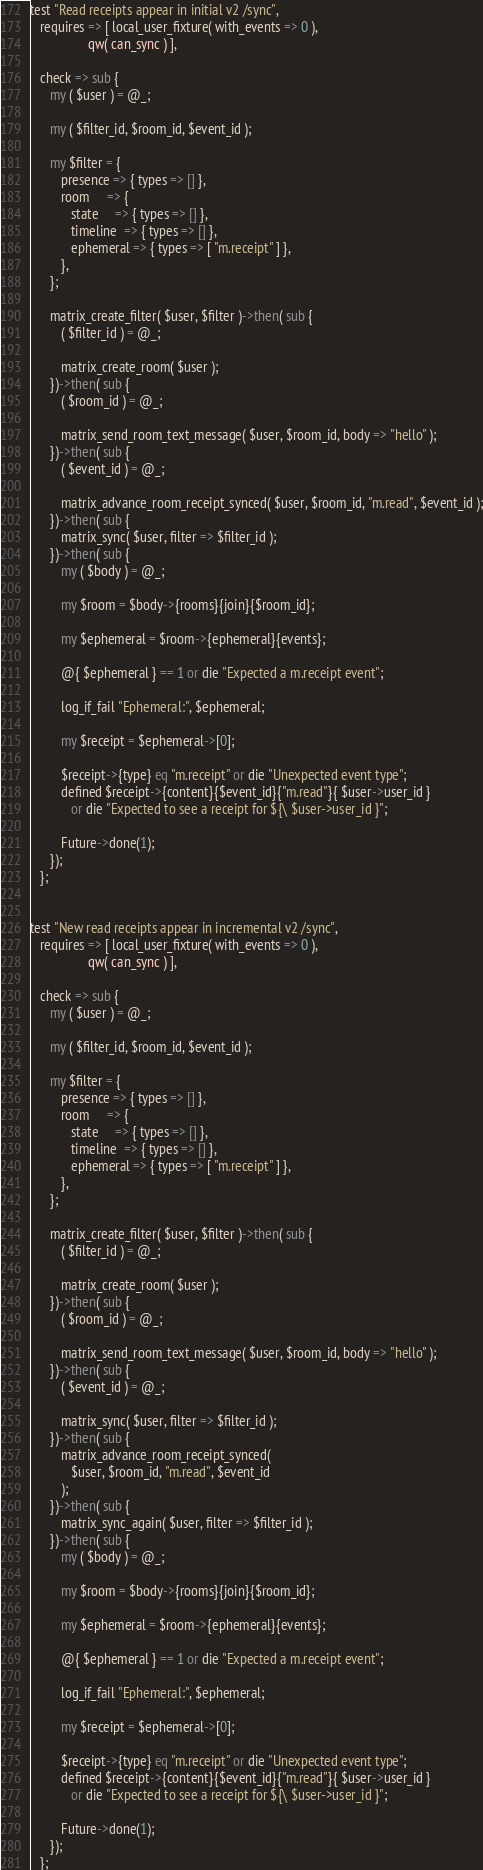Convert code to text. <code><loc_0><loc_0><loc_500><loc_500><_Perl_>test "Read receipts appear in initial v2 /sync",
   requires => [ local_user_fixture( with_events => 0 ),
                 qw( can_sync ) ],

   check => sub {
      my ( $user ) = @_;

      my ( $filter_id, $room_id, $event_id );

      my $filter = {
         presence => { types => [] },
         room     => {
            state     => { types => [] },
            timeline  => { types => [] },
            ephemeral => { types => [ "m.receipt" ] },
         },
      };

      matrix_create_filter( $user, $filter )->then( sub {
         ( $filter_id ) = @_;

         matrix_create_room( $user );
      })->then( sub {
         ( $room_id ) = @_;

         matrix_send_room_text_message( $user, $room_id, body => "hello" );
      })->then( sub {
         ( $event_id ) = @_;

         matrix_advance_room_receipt_synced( $user, $room_id, "m.read", $event_id );
      })->then( sub {
         matrix_sync( $user, filter => $filter_id );
      })->then( sub {
         my ( $body ) = @_;

         my $room = $body->{rooms}{join}{$room_id};

         my $ephemeral = $room->{ephemeral}{events};

         @{ $ephemeral } == 1 or die "Expected a m.receipt event";

         log_if_fail "Ephemeral:", $ephemeral;

         my $receipt = $ephemeral->[0];

         $receipt->{type} eq "m.receipt" or die "Unexpected event type";
         defined $receipt->{content}{$event_id}{"m.read"}{ $user->user_id }
            or die "Expected to see a receipt for ${\ $user->user_id }";

         Future->done(1);
      });
   };


test "New read receipts appear in incremental v2 /sync",
   requires => [ local_user_fixture( with_events => 0 ),
                 qw( can_sync ) ],

   check => sub {
      my ( $user ) = @_;

      my ( $filter_id, $room_id, $event_id );

      my $filter = {
         presence => { types => [] },
         room     => {
            state     => { types => [] },
            timeline  => { types => [] },
            ephemeral => { types => [ "m.receipt" ] },
         },
      };

      matrix_create_filter( $user, $filter )->then( sub {
         ( $filter_id ) = @_;

         matrix_create_room( $user );
      })->then( sub {
         ( $room_id ) = @_;

         matrix_send_room_text_message( $user, $room_id, body => "hello" );
      })->then( sub {
         ( $event_id ) = @_;

         matrix_sync( $user, filter => $filter_id );
      })->then( sub {
         matrix_advance_room_receipt_synced(
            $user, $room_id, "m.read", $event_id
         );
      })->then( sub {
         matrix_sync_again( $user, filter => $filter_id );
      })->then( sub {
         my ( $body ) = @_;

         my $room = $body->{rooms}{join}{$room_id};

         my $ephemeral = $room->{ephemeral}{events};

         @{ $ephemeral } == 1 or die "Expected a m.receipt event";

         log_if_fail "Ephemeral:", $ephemeral;

         my $receipt = $ephemeral->[0];

         $receipt->{type} eq "m.receipt" or die "Unexpected event type";
         defined $receipt->{content}{$event_id}{"m.read"}{ $user->user_id }
            or die "Expected to see a receipt for ${\ $user->user_id }";

         Future->done(1);
      });
   };
</code> 